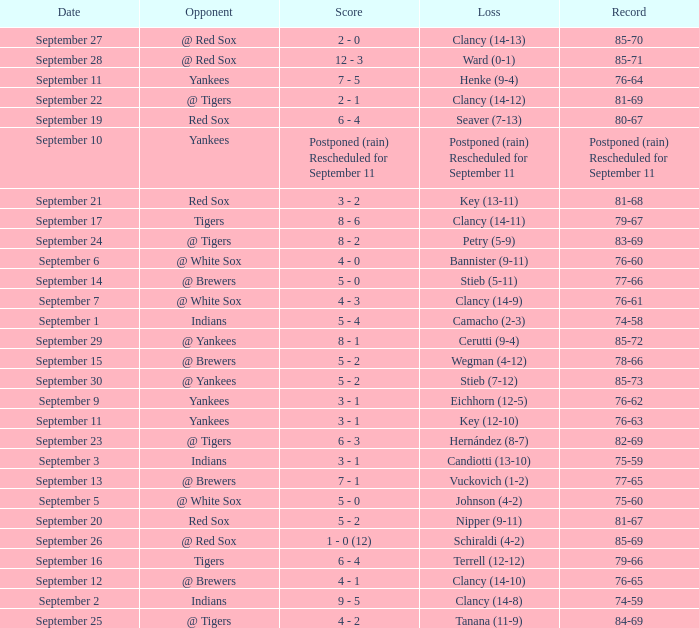What was the date of the game when their record was 84-69? September 25. 